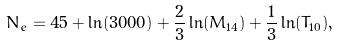<formula> <loc_0><loc_0><loc_500><loc_500>N _ { e } = 4 5 + \ln ( 3 0 0 0 ) + \frac { 2 } { 3 } \ln ( M _ { 1 4 } ) + \frac { 1 } { 3 } \ln ( T _ { 1 0 } ) ,</formula> 